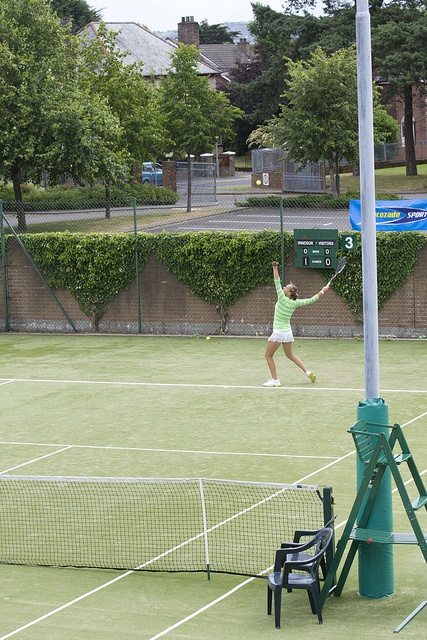Describe the objects in this image and their specific colors. I can see chair in darkgreen, black, gray, darkgray, and olive tones, people in darkgreen, lightgray, gray, lightgreen, and tan tones, chair in darkgreen and teal tones, tennis racket in darkgreen, gray, black, lightgray, and darkgray tones, and sports ball in darkgreen, khaki, beige, and olive tones in this image. 